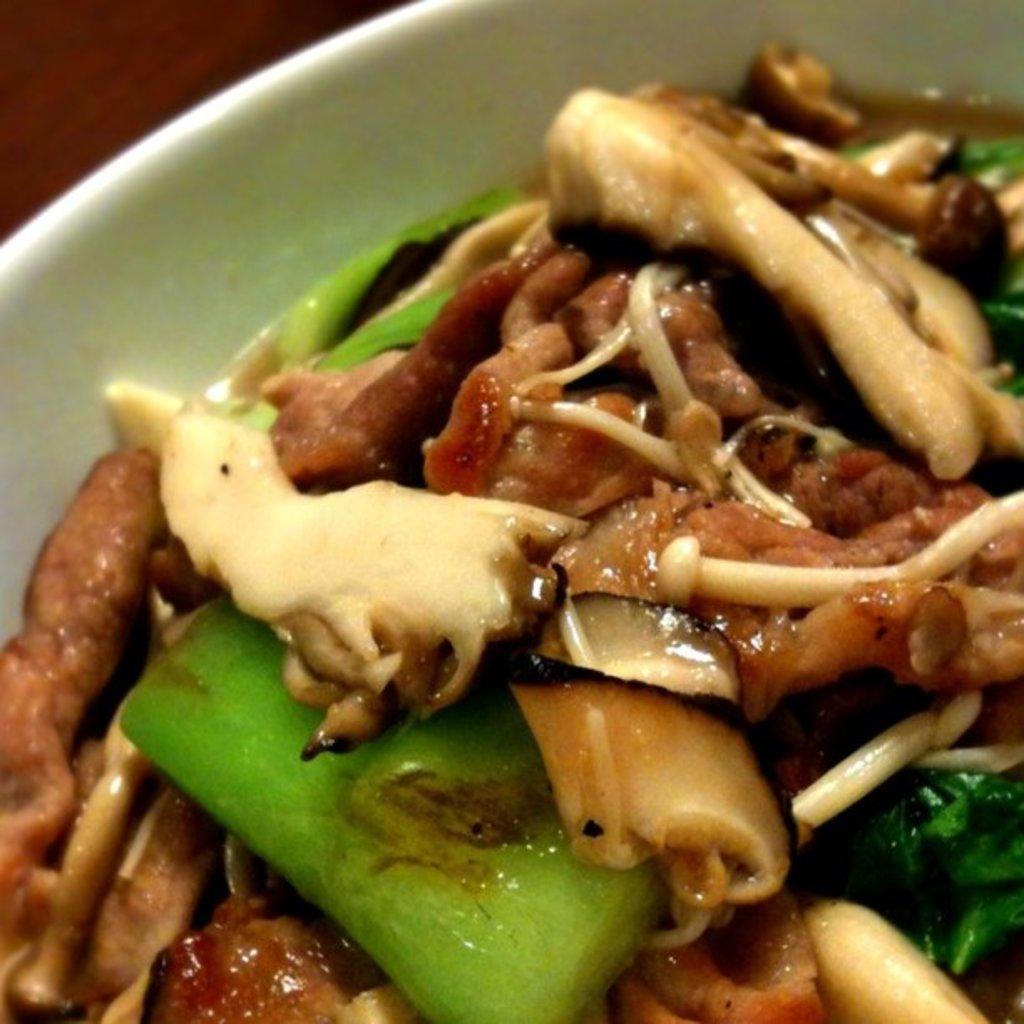How would you summarize this image in a sentence or two? This is a zoomed in picture. In the center there is a white color palette containing some food item. In the background there is a brown color object. 